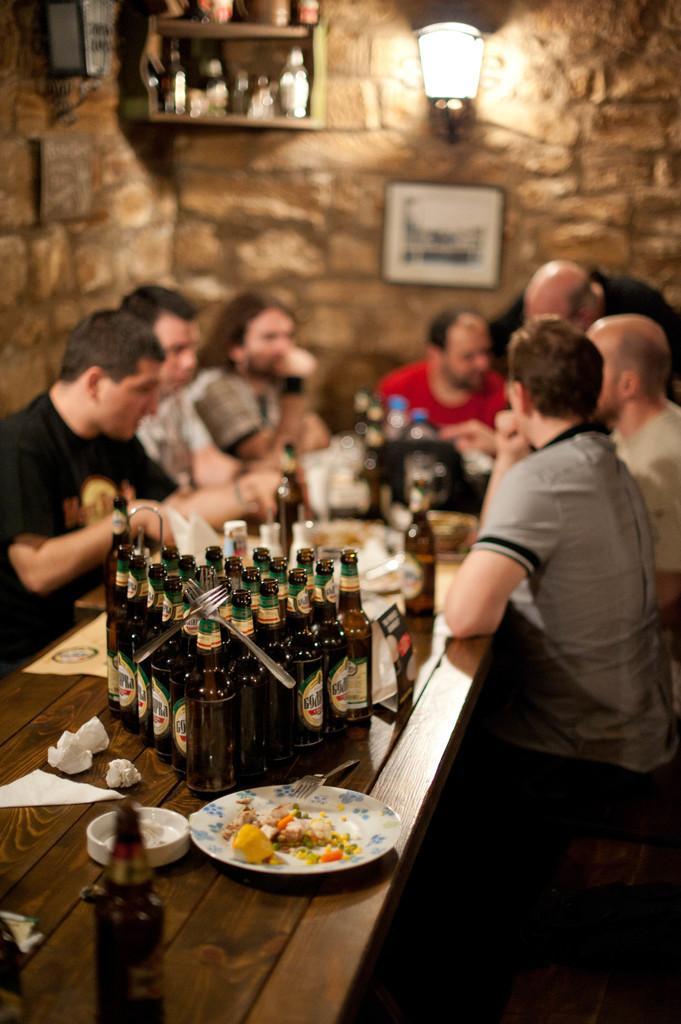Please provide a concise description of this image. In this image, There is a table which is in brown color on that there are some wine bottle s which are in black color, There are some people sitting on the chairs, In the background there is a yellow color wall and there is a light which is in white color. 